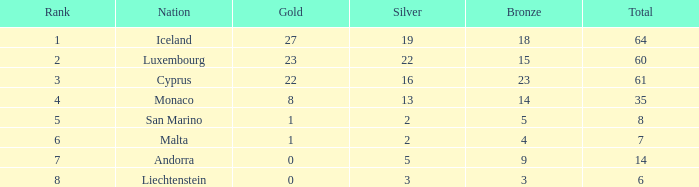What is the count of bronze medals for iceland when they have more than 2 silvers? 18.0. 